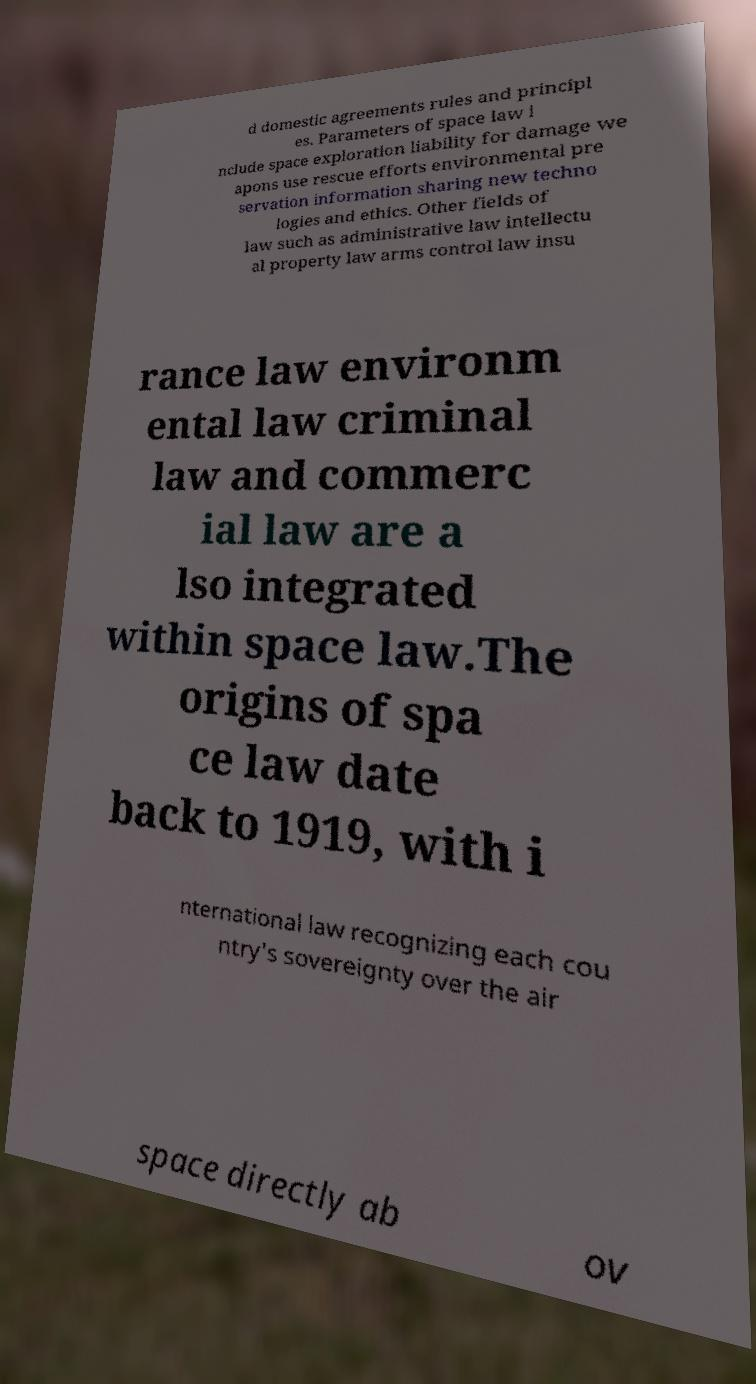Please identify and transcribe the text found in this image. d domestic agreements rules and principl es. Parameters of space law i nclude space exploration liability for damage we apons use rescue efforts environmental pre servation information sharing new techno logies and ethics. Other fields of law such as administrative law intellectu al property law arms control law insu rance law environm ental law criminal law and commerc ial law are a lso integrated within space law.The origins of spa ce law date back to 1919, with i nternational law recognizing each cou ntry's sovereignty over the air space directly ab ov 